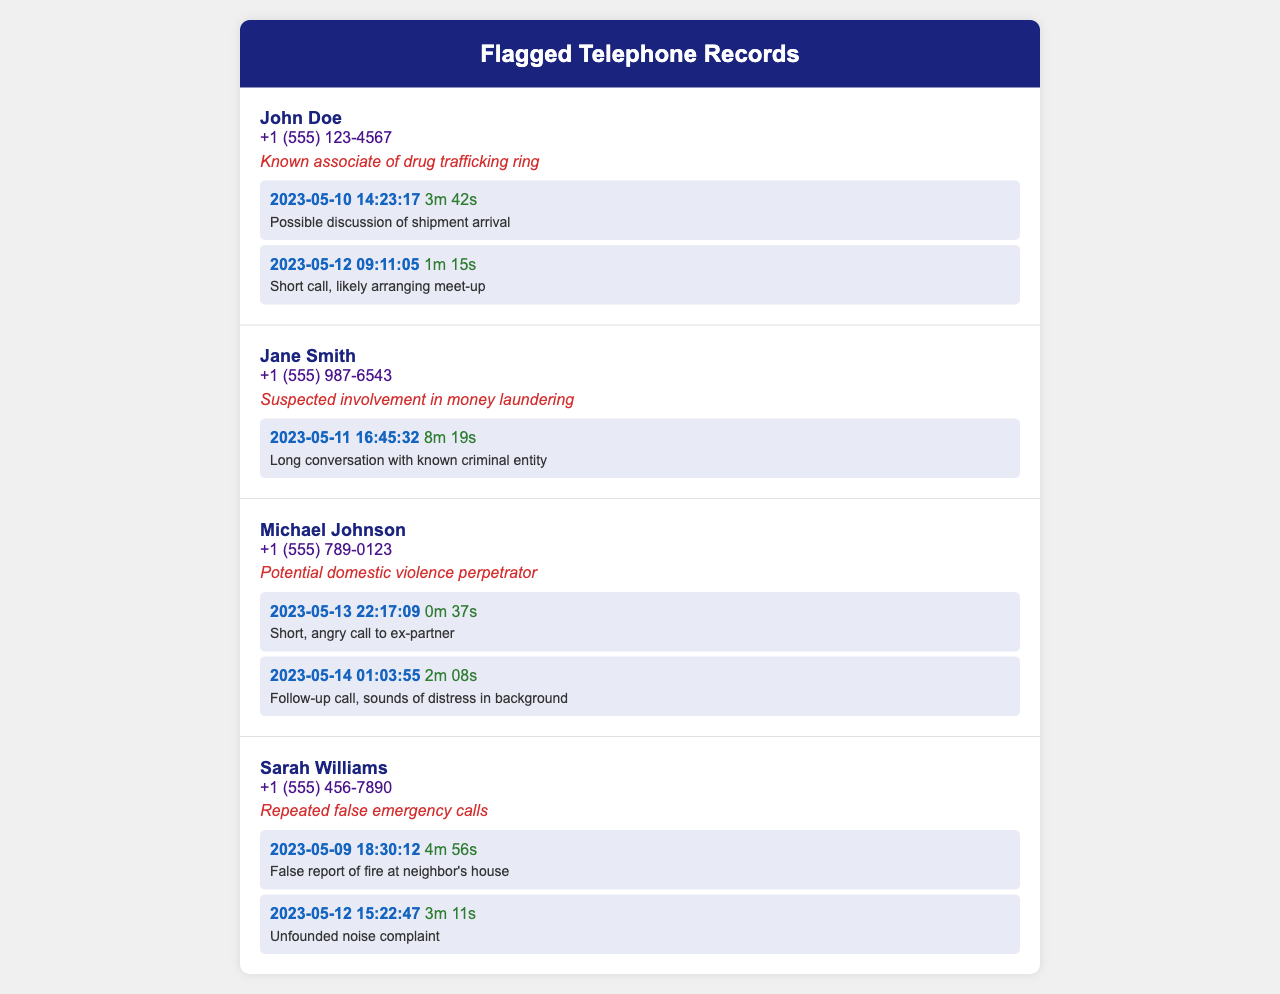What is the phone number of John Doe? The document provides John Doe's contact information as +1 (555) 123-4567.
Answer: +1 (555) 123-4567 How many calls did Sarah Williams make? The number of calls made by Sarah Williams can be found under her record, showing two calls listed.
Answer: 2 What was the duration of Jane Smith's longest call? The longest call is indicated in the records for Jane Smith and lasts 8 minutes and 19 seconds.
Answer: 8m 19s What is the reason for flagging Michael Johnson? The document states that Michael Johnson is flagged due to his potential involvement in domestic violence.
Answer: Potential domestic violence perpetrator When did the most recent call from John Doe take place? The timestamp for the most recent call made by John Doe is shown as May 12, 2023, at 09:11:05.
Answer: 2023-05-12 09:11:05 What incident did Sarah Williams falsely report? The record notes a false report made by Sarah Williams regarding a fire at her neighbor's house.
Answer: Fire at neighbor's house Who had a call that included sounds of distress in the background? The call notes detail that Michael Johnson's follow-up call had sounds of distress in the background.
Answer: Michael Johnson What was the purpose of John Doe's short call on May 12, 2023? The notes describe the short call as likely arranging a meet-up, indicating its context.
Answer: Arranging meet-up 